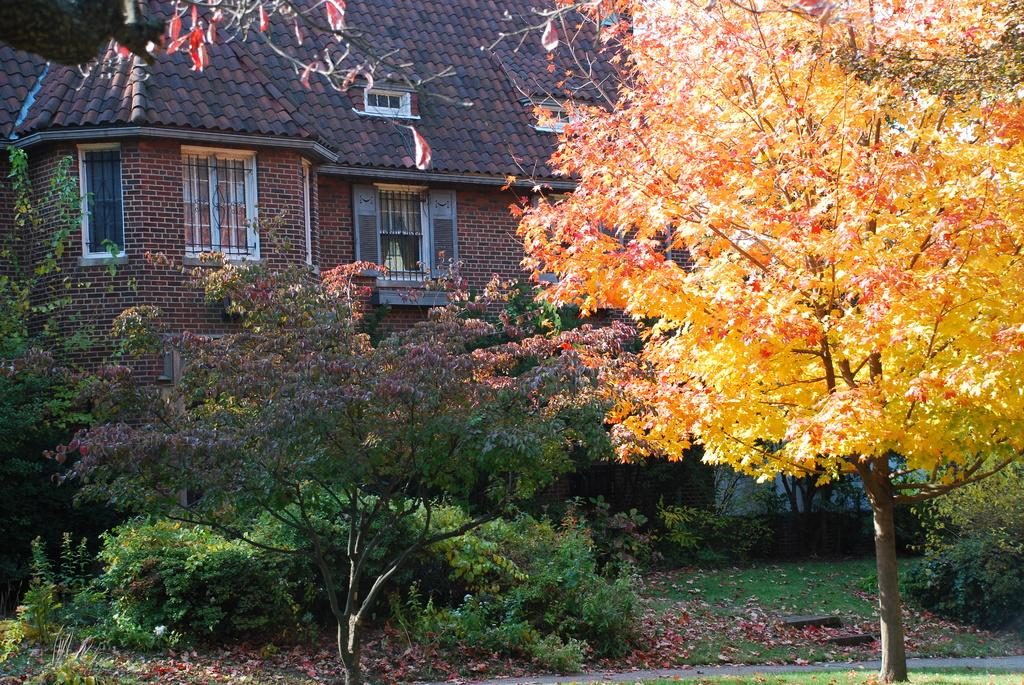What type of vegetation can be seen in the foreground of the image? There are trees and plants in the foreground of the image. What type of structure is visible in the background of the image? There is a house in the background of the image. What type of ground cover is present at the bottom of the image? Grass is present at the bottom of the image. What additional detail can be observed at the bottom of the image? Dry leaves are visible at the bottom of the image. How many bottles can be seen in the image? There are no bottles present in the image. What type of creatures are crawling on the trees in the image? There are no creatures, such as lizards, present in the image. 